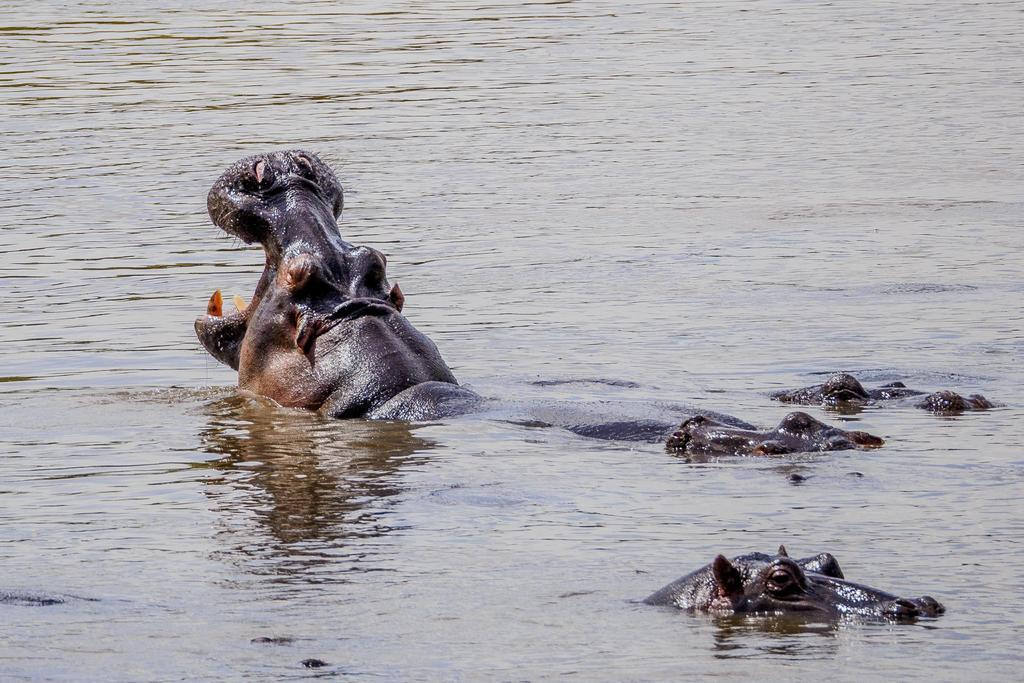What animals can be seen in the water in the image? There are hippopotamuses in the water. What colors are the hippopotamuses in the image? The hippopotamuses are black and light brown in color. What type of education do the hippopotamuses receive in the image? There is no indication in the image that the hippopotamuses are receiving any education. 